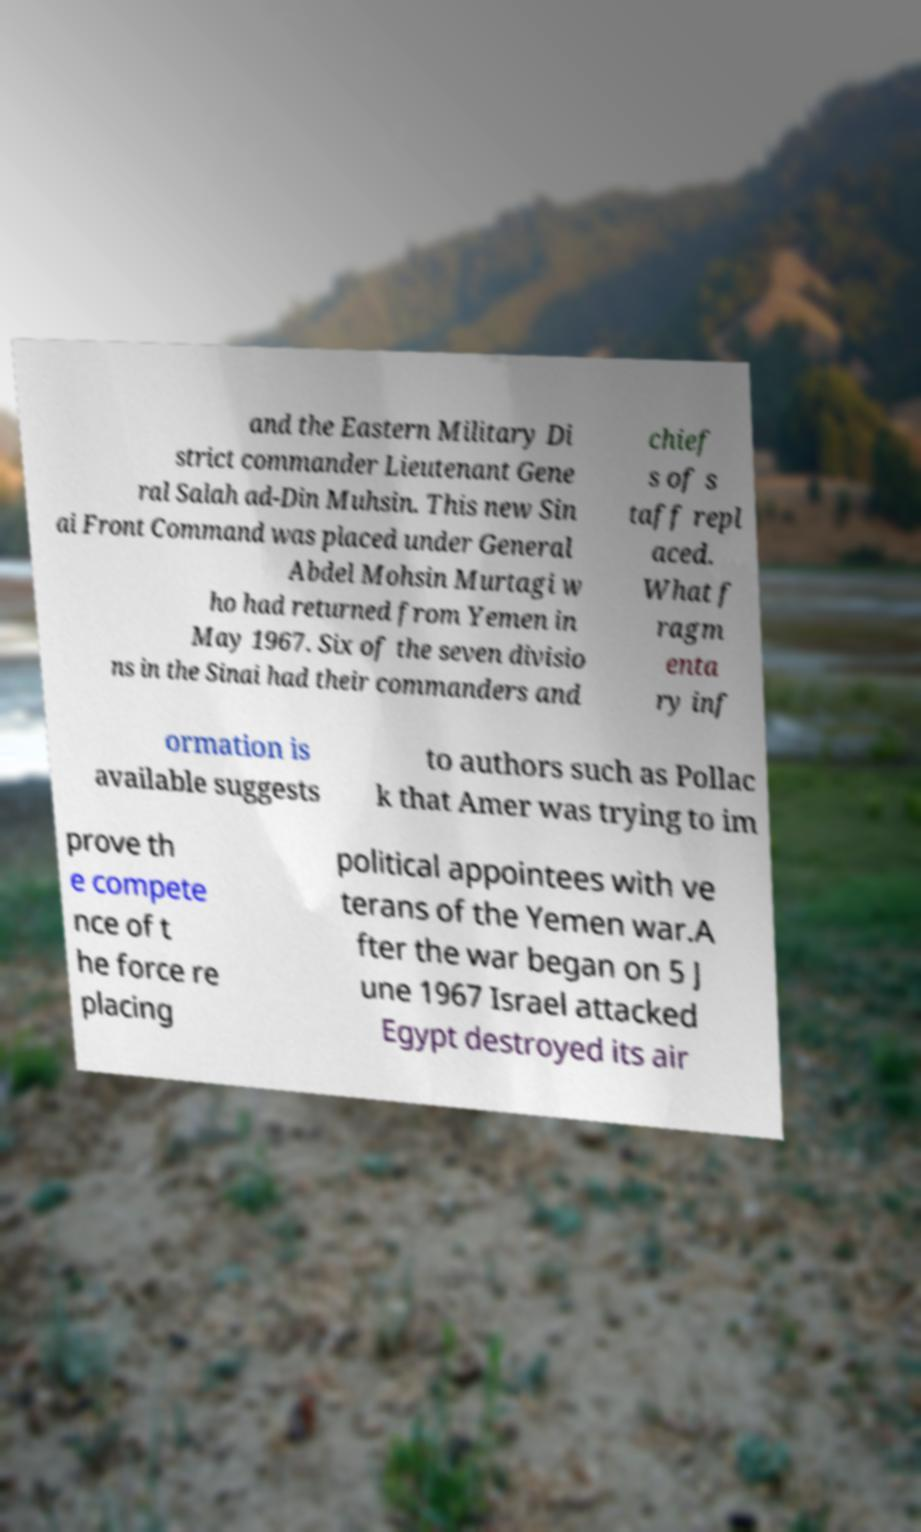For documentation purposes, I need the text within this image transcribed. Could you provide that? and the Eastern Military Di strict commander Lieutenant Gene ral Salah ad-Din Muhsin. This new Sin ai Front Command was placed under General Abdel Mohsin Murtagi w ho had returned from Yemen in May 1967. Six of the seven divisio ns in the Sinai had their commanders and chief s of s taff repl aced. What f ragm enta ry inf ormation is available suggests to authors such as Pollac k that Amer was trying to im prove th e compete nce of t he force re placing political appointees with ve terans of the Yemen war.A fter the war began on 5 J une 1967 Israel attacked Egypt destroyed its air 